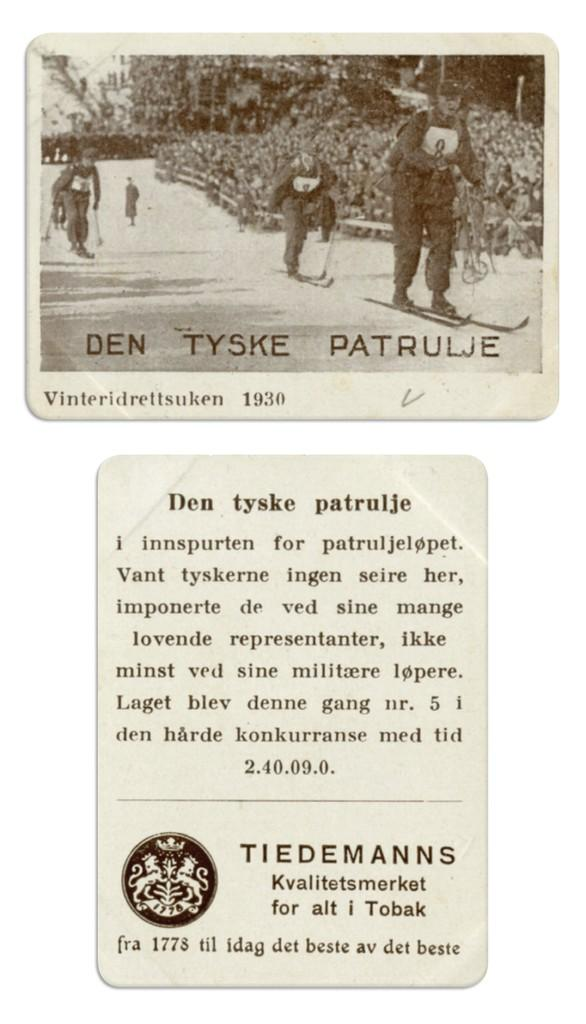What can be found written at the bottom of the image? There is text written at the bottom of the image. What activity are the persons in the image engaged in? The persons are skiing in the image. On what surface are the persons skiing? The persons are skiing on snow. What type of natural environment is visible in the image? There are trees in the image, indicating a forest or wooded area. What type of education is being taught in the image? There is no indication of education being taught in the image; it features persons skiing on snow with trees in the background. Can you tell me how many steps are visible in the image? There are no steps present in the image; it features persons skiing on snow with trees in the background. 